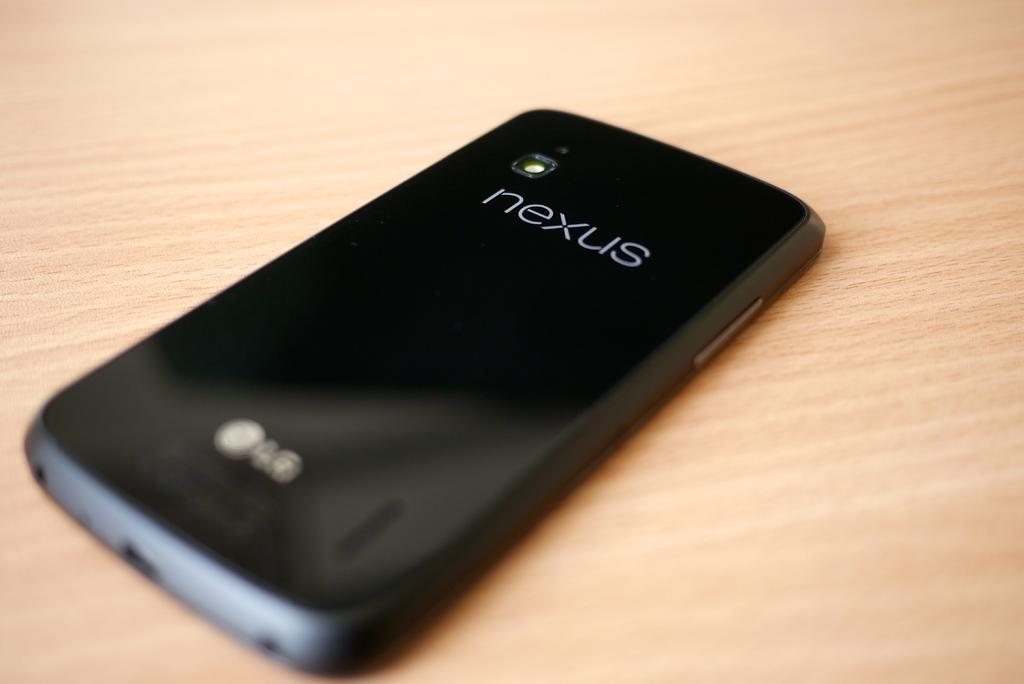<image>
Summarize the visual content of the image. A Nexus phone is sitting on a table. 